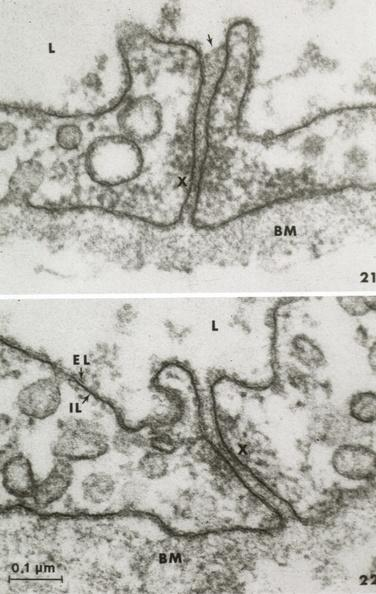s acid present?
Answer the question using a single word or phrase. No 